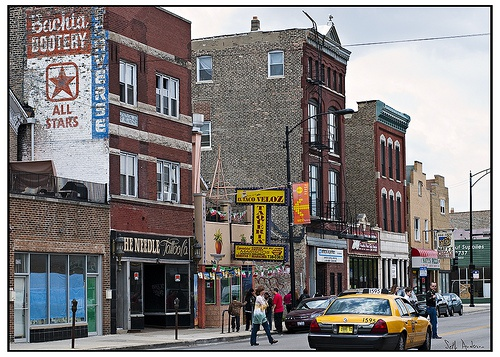Describe the objects in this image and their specific colors. I can see car in white, black, lightgray, gray, and tan tones, car in white, black, gray, darkgray, and lightgray tones, people in white, black, gray, lightgray, and darkgray tones, people in white, black, navy, gray, and lightgray tones, and car in white, black, gray, lightgray, and darkgray tones in this image. 